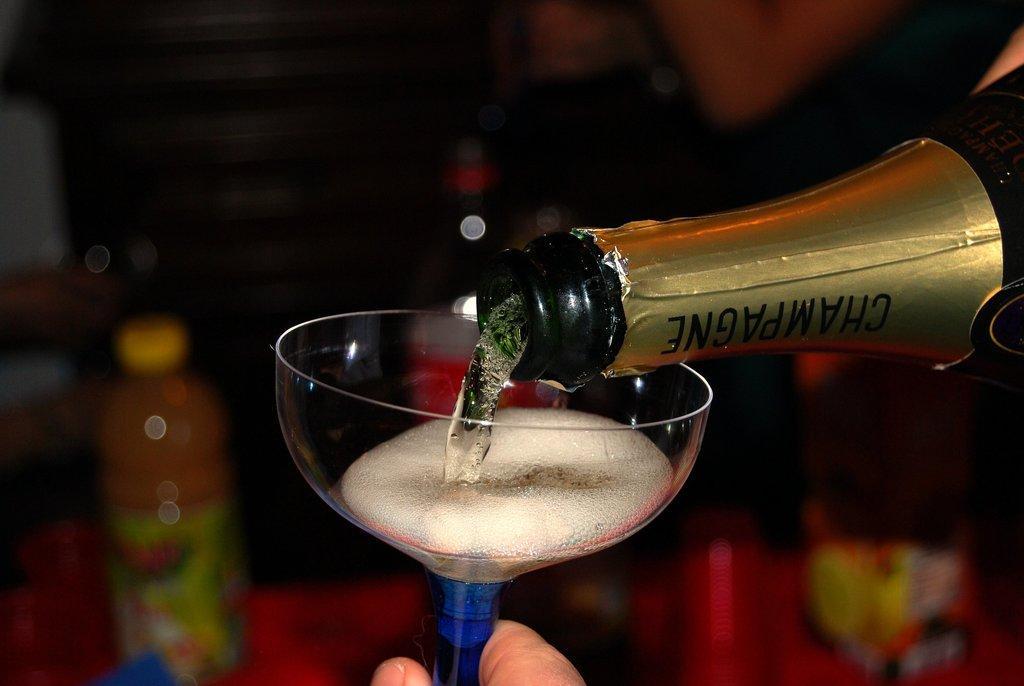Describe this image in one or two sentences. In this picture we can see glass with drink in it and from bottle it is falling and in background we can see other bottle and it is blurry. 